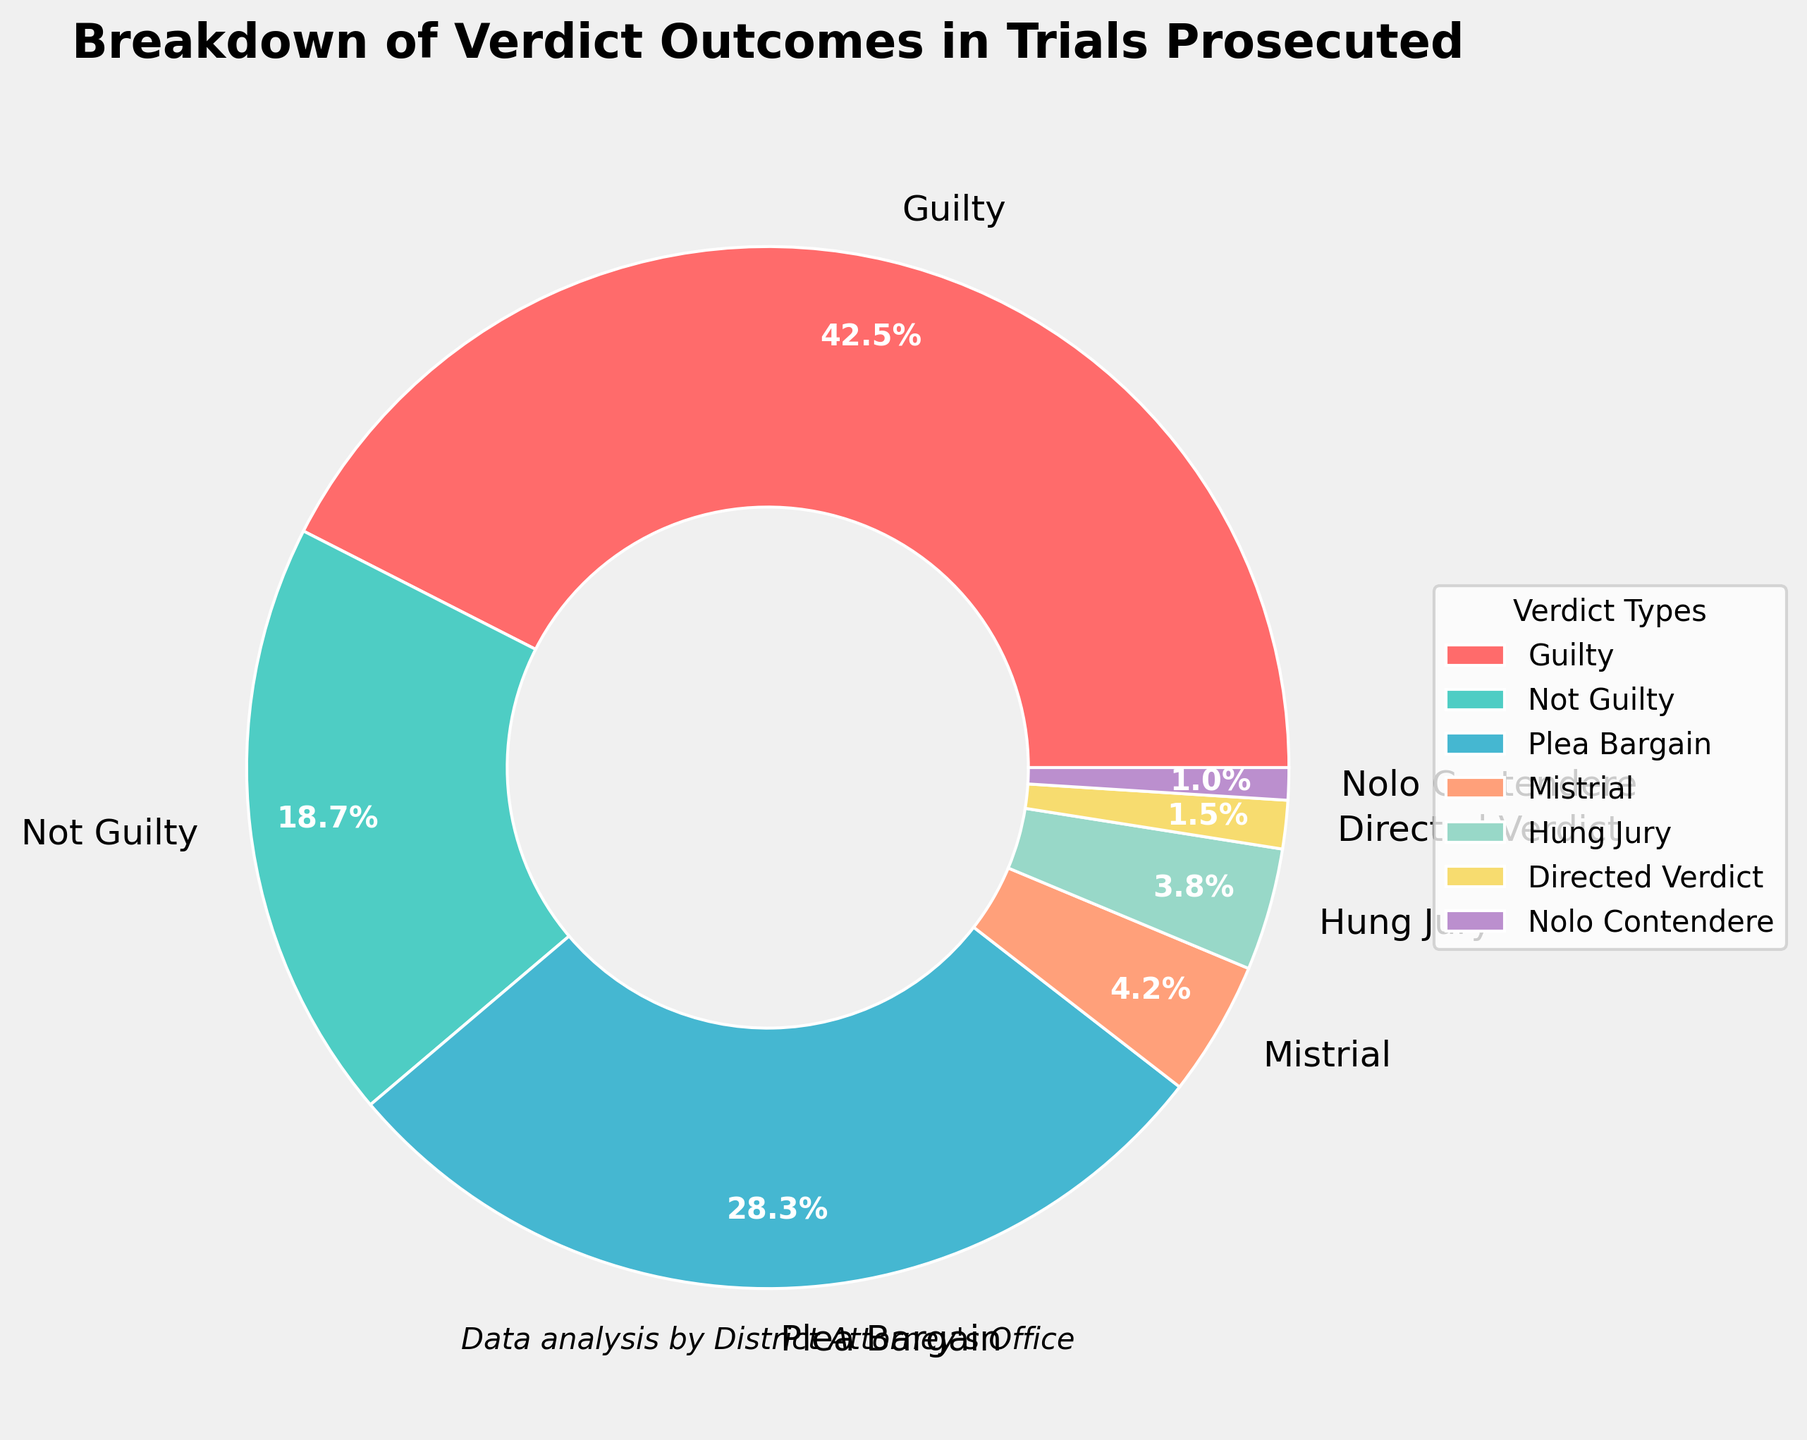What's the most common verdict outcome? By looking at the pie chart, we can see that the "Guilty" slice is the largest, indicating it has the highest percentage.
Answer: Guilty Which two verdict outcomes together make up more than half of the total verdicts? Adding the percentages for "Guilty" (42.5%) and "Plea Bargain" (28.3%) results in a sum of 70.8%, which is more than half of the total.
Answer: Guilty and Plea Bargain What is the difference in percentage between "Guilty" and "Not Guilty" verdicts? Subtract the percentage of "Not Guilty" (18.7%) from "Guilty" (42.5%). 42.5% - 18.7% = 23.8%.
Answer: 23.8% Which verdict outcome has the smallest percentage? The smallest slice of the pie represents "Nolo Contendere," which has the smallest percentage of 1.0%.
Answer: Nolo Contendere How many verdict outcomes are less than 5% each? By examining the slices of the pie, "Mistrial" (4.2%), "Hung Jury" (3.8%), "Directed Verdict" (1.5%), and "Nolo Contendere" (1.0%) all have percentages less than 5%. There are 4 such outcomes.
Answer: 4 Compare the combined percentage of "Mistrial" and "Hung Jury" to "Not Guilty." Add the percentages of "Mistrial" (4.2%) and "Hung Jury" (3.8%) to get 8.0%, and compare it to "Not Guilty" (18.7%). 8.0% is less than 18.7%.
Answer: Less What is the total percentage of all verdict outcomes given in the chart? Sum all the provided percentages: 42.5% + 18.7% + 28.3% + 4.2% + 3.8% + 1.5% + 1.0% = 100%.
Answer: 100% Which verdict outcome is represented by the lightest shade of color? The "No Contest" (Nolo Contendere) outcome is represented by a very light color in the chart.
Answer: Nolo Contendere Out of "Plea Bargain" and "Not Guilty," which has the higher percentage, and by how much? Compare "Plea Bargain" (28.3%) to "Not Guilty" (18.7%) and calculate the difference. 28.3% - 18.7% = 9.6%.
Answer: Plea Bargain by 9.6% What percentage of cases resulted in outcomes other than "Guilty" and "Not Guilty"? Sum the percentages of all other outcomes: 28.3% (Plea Bargain) + 4.2% (Mistrial) + 3.8% (Hung Jury) + 1.5% (Directed Verdict) + 1.0% (Nolo Contendere) to get 38.8%.
Answer: 38.8% 